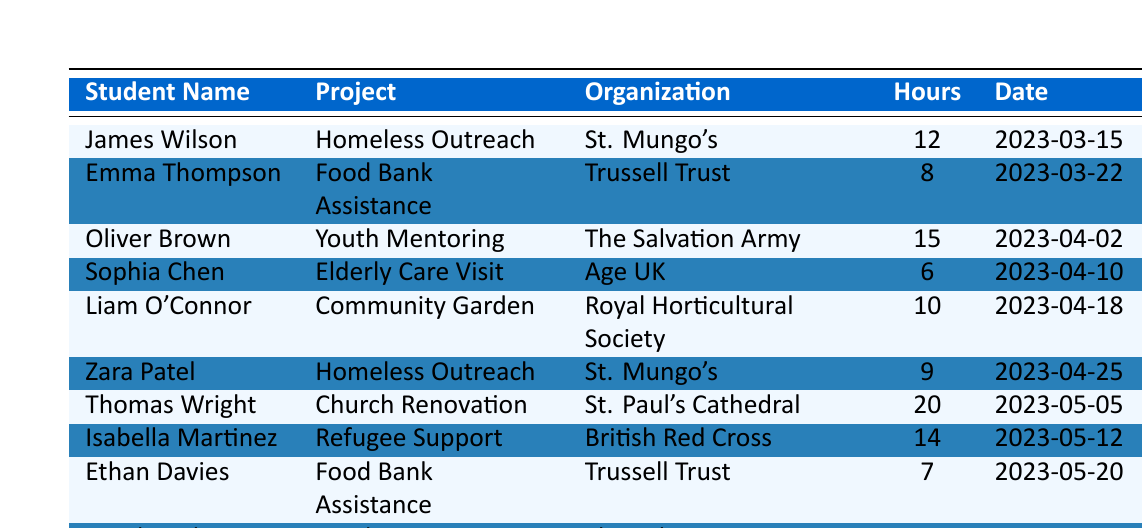What is the total number of volunteer hours logged by all members? To find the total number of volunteer hours, we add up the hours from all entries in the table: 12 + 8 + 15 + 6 + 10 + 9 + 20 + 14 + 7 + 18 = 119.
Answer: 119 Who volunteered the most hours and how many hours did they log? By checking the hours logged by each member, Thomas Wright volunteered the most with 20 hours.
Answer: Thomas Wright, 20 hours How many different community service projects are listed in the table? The projects listed are Homeless Outreach, Food Bank Assistance, Youth Mentoring, Elderly Care Visit, Community Garden, Church Renovation, and Refugee Support. This totals to 7 distinct projects.
Answer: 7 Which student logged hours for the Food Bank Assistance project? The students who logged hours for Food Bank Assistance are Emma Thompson and Ethan Davies.
Answer: Emma Thompson and Ethan Davies What is the average number of hours logged per student? There are 10 students with a total of 119 hours. The average is calculated as 119 hours divided by 10 students, which equals 11.9.
Answer: 11.9 hours Did any member volunteer for both Youth Mentoring and Food Bank Assistance? A check of the projects shows that Oliver Brown (Youth Mentoring) and Ethan Davies (Food Bank Assistance) are two different students; hence, no member volunteered for both.
Answer: No What is the total number of hours logged for the Homeless Outreach project? James Wilson logged 12 hours and Zara Patel logged 9 hours for Homeless Outreach, so the total is 12 + 9 = 21 hours.
Answer: 21 hours Which organization had the highest number of total volunteer hours logged? The organization with the highest total is The Salvation Army, contributing 15 (Oliver Brown) + 18 (Amelia Johnson) = 33 hours.
Answer: The Salvation Army, 33 hours How many students participated in the Elderly Care Visit project? Only one student, Sophia Chen, volunteered for Elderly Care Visit, contributing 6 hours.
Answer: 1 student Is it true that no one volunteered for the Community Garden project? A look at the data shows that Liam O'Connor logged 10 hours for the Community Garden project, so it is not true.
Answer: False 